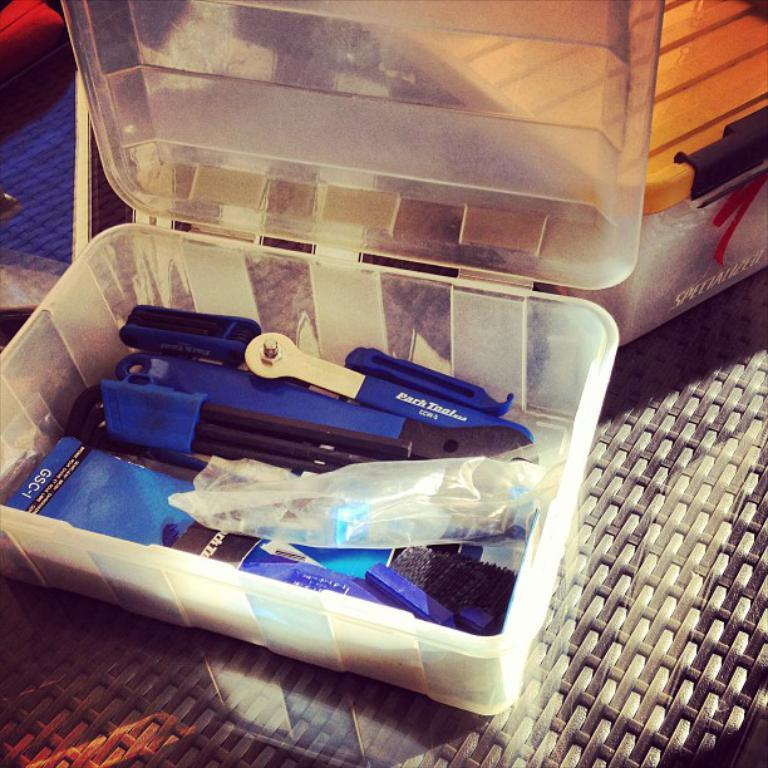What is the main container in the image? There are objects in a plastic box on a platform. What type of items can be found in the plastic box? Small brushes are present in the plastic box. How is the plastic box sealed or protected? There is a cover in the plastic box. Can you describe the background of the image? There is another plastic box in the background. What is inside the background plastic box? There is an object in the background plastic box. What type of yoke is present in the image? There is no yoke present in the image. What color is the vase in the background plastic box? There is no vase present in the image. 